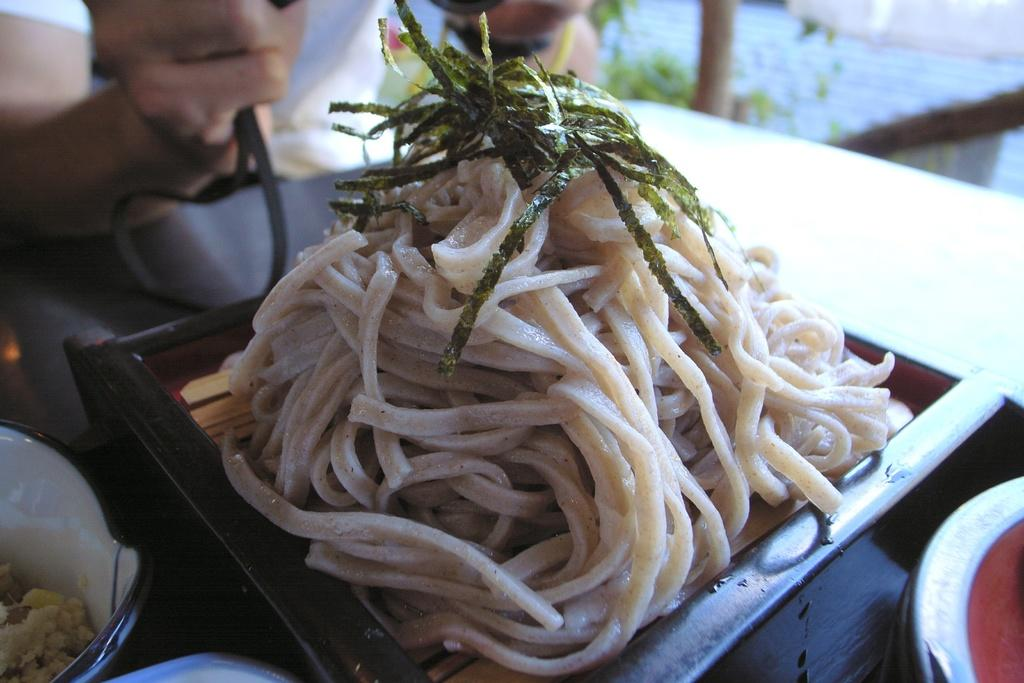What is on the tray in the image? There are food items on the tray in the image. Where is the tray located? The tray is on a table. Can you describe anything else visible in the image? There is a person's hand visible in front of the tray. What type of shirt is the person wearing in the image? There is no shirt visible in the image, only a person's hand is visible in front of the tray. How many items are being sorted on the tray? There is no indication of sorting in the image; the food items are simply on the tray. 